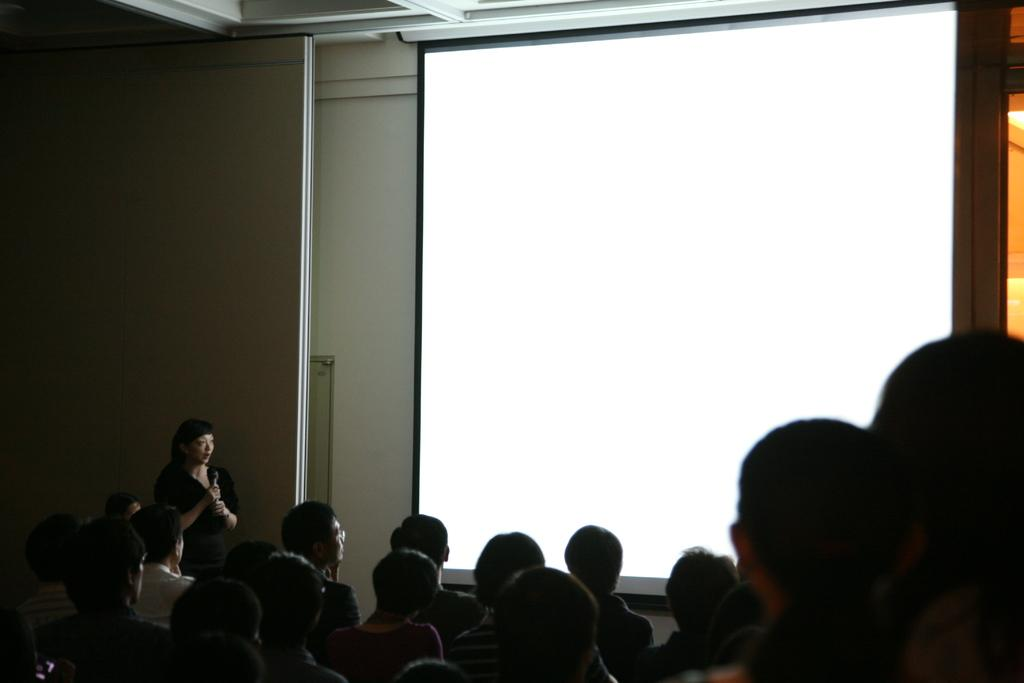What is the main object in the image? There is a projector screen in the image. What else can be seen in the image besides the projector screen? There is a group of people in the image. Can you describe the position of one person in the group? A woman is standing beside a wall in the image. What type of animal can be seen bursting through the projector screen in the image? There is no animal present in the image, nor is there any indication of something bursting through the projector screen. 